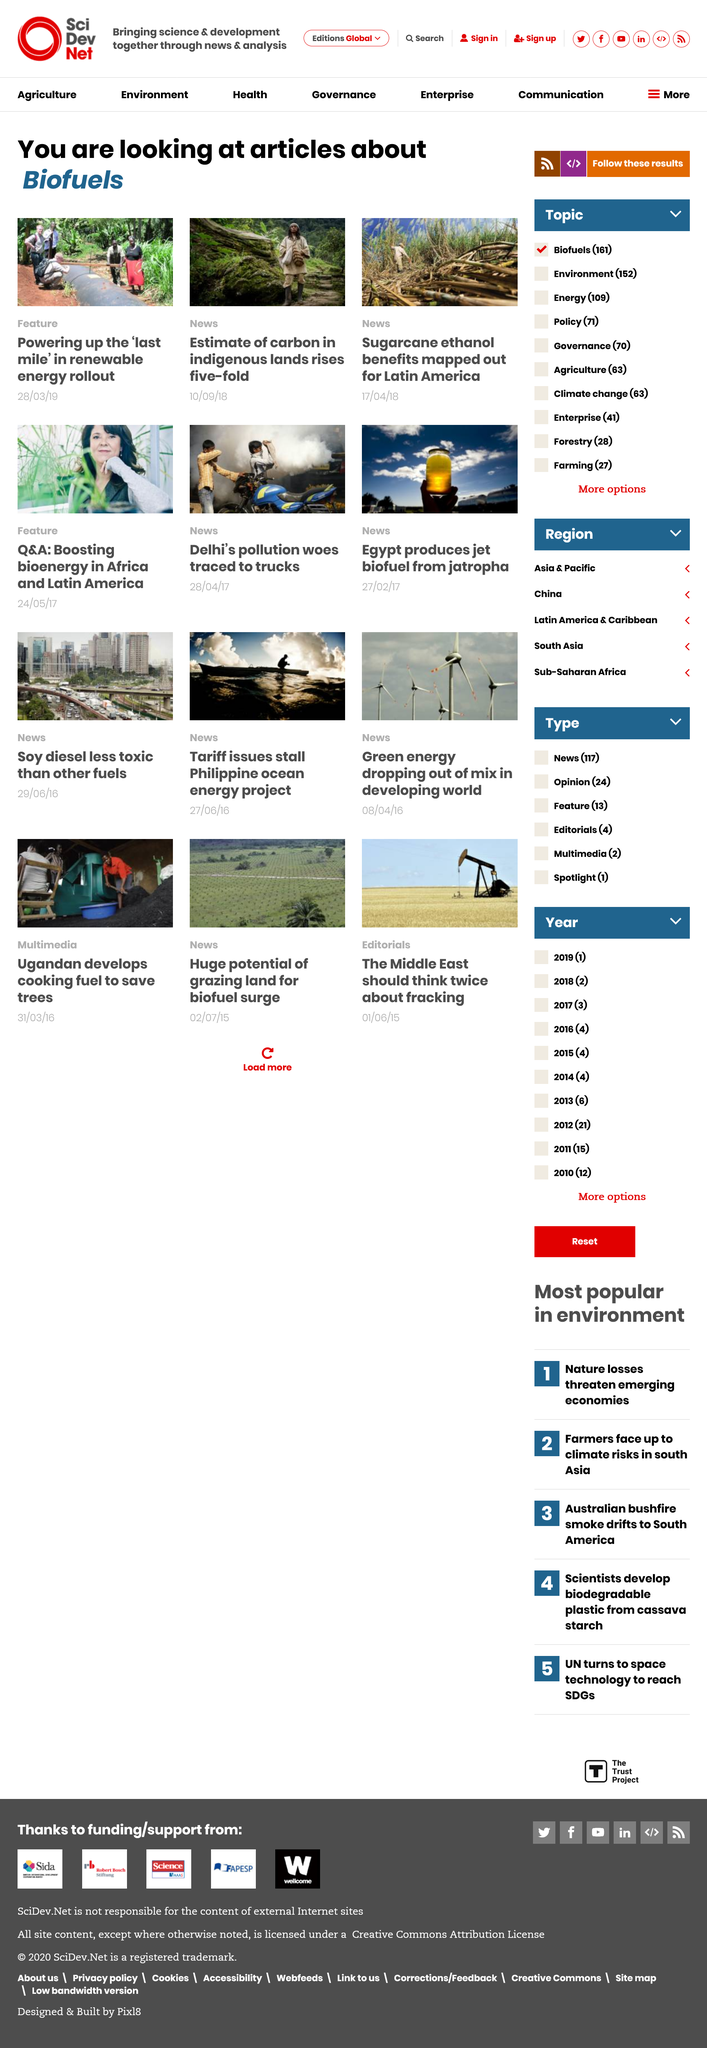Indicate a few pertinent items in this graphic. The benefits of sugarcane ethanol in Latin America are being mapped out in an article about biofuels. The estimate of carbon in indigenous lands rose by a five-fold increase. The article about the benefits of sugarcane ethanol is classified under the News category. 